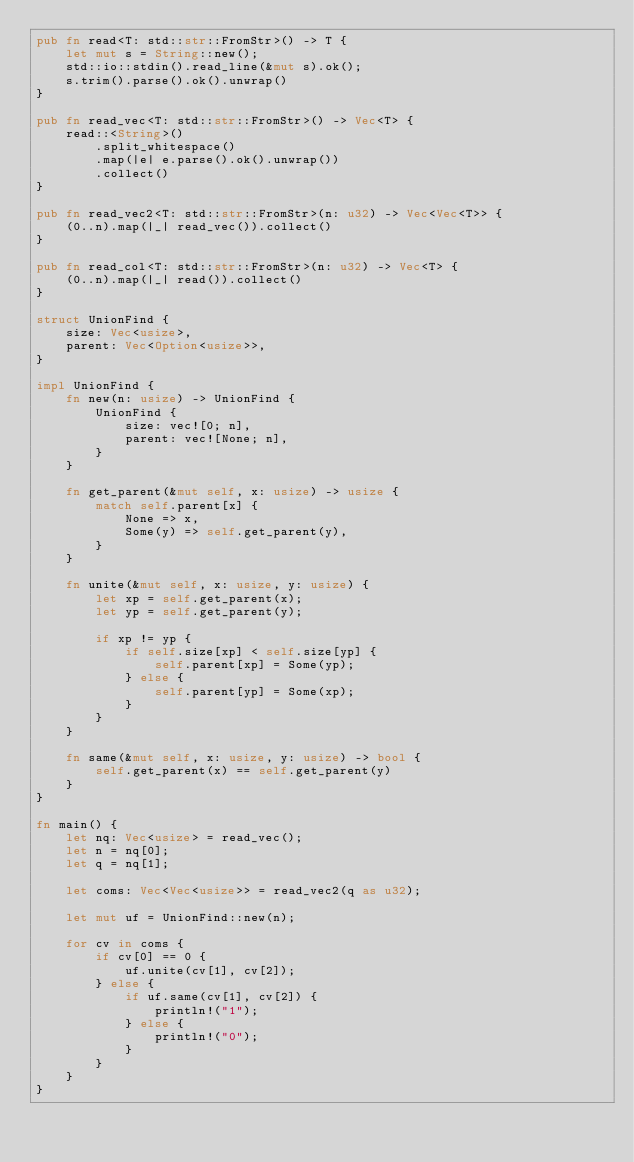Convert code to text. <code><loc_0><loc_0><loc_500><loc_500><_Rust_>pub fn read<T: std::str::FromStr>() -> T {
    let mut s = String::new();
    std::io::stdin().read_line(&mut s).ok();
    s.trim().parse().ok().unwrap()
}

pub fn read_vec<T: std::str::FromStr>() -> Vec<T> {
    read::<String>()
        .split_whitespace()
        .map(|e| e.parse().ok().unwrap())
        .collect()
}

pub fn read_vec2<T: std::str::FromStr>(n: u32) -> Vec<Vec<T>> {
    (0..n).map(|_| read_vec()).collect()
}

pub fn read_col<T: std::str::FromStr>(n: u32) -> Vec<T> {
    (0..n).map(|_| read()).collect()
}

struct UnionFind {
    size: Vec<usize>,
    parent: Vec<Option<usize>>,
}

impl UnionFind {
    fn new(n: usize) -> UnionFind {
        UnionFind {
            size: vec![0; n],
            parent: vec![None; n],
        }
    }

    fn get_parent(&mut self, x: usize) -> usize {
        match self.parent[x] {
            None => x,
            Some(y) => self.get_parent(y),
        }
    }

    fn unite(&mut self, x: usize, y: usize) {
        let xp = self.get_parent(x);
        let yp = self.get_parent(y);

        if xp != yp {
            if self.size[xp] < self.size[yp] {
                self.parent[xp] = Some(yp);
            } else {
                self.parent[yp] = Some(xp);
            }
        }
    }

    fn same(&mut self, x: usize, y: usize) -> bool {
        self.get_parent(x) == self.get_parent(y)
    }
}

fn main() {
    let nq: Vec<usize> = read_vec();
    let n = nq[0];
    let q = nq[1];

    let coms: Vec<Vec<usize>> = read_vec2(q as u32);

    let mut uf = UnionFind::new(n);

    for cv in coms {
        if cv[0] == 0 {
            uf.unite(cv[1], cv[2]);
        } else {
            if uf.same(cv[1], cv[2]) {
                println!("1");
            } else {
                println!("0");
            }
        }
    }
}

</code> 